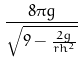<formula> <loc_0><loc_0><loc_500><loc_500>\frac { 8 \pi g } { \sqrt { 9 - \frac { 2 g } { r h ^ { 2 } } } }</formula> 